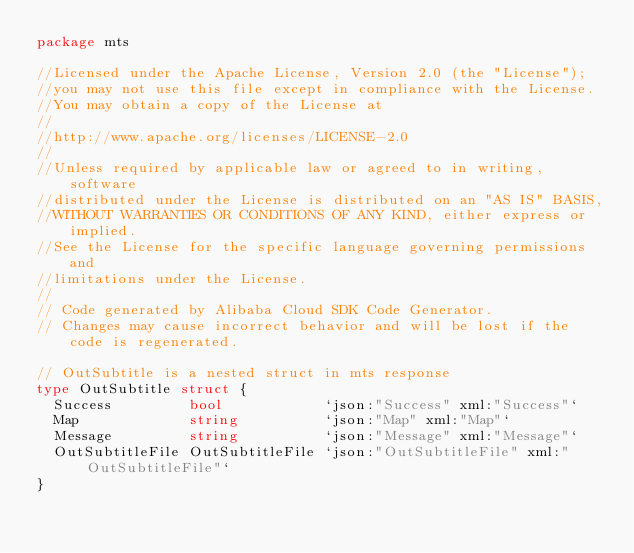<code> <loc_0><loc_0><loc_500><loc_500><_Go_>package mts

//Licensed under the Apache License, Version 2.0 (the "License");
//you may not use this file except in compliance with the License.
//You may obtain a copy of the License at
//
//http://www.apache.org/licenses/LICENSE-2.0
//
//Unless required by applicable law or agreed to in writing, software
//distributed under the License is distributed on an "AS IS" BASIS,
//WITHOUT WARRANTIES OR CONDITIONS OF ANY KIND, either express or implied.
//See the License for the specific language governing permissions and
//limitations under the License.
//
// Code generated by Alibaba Cloud SDK Code Generator.
// Changes may cause incorrect behavior and will be lost if the code is regenerated.

// OutSubtitle is a nested struct in mts response
type OutSubtitle struct {
	Success         bool            `json:"Success" xml:"Success"`
	Map             string          `json:"Map" xml:"Map"`
	Message         string          `json:"Message" xml:"Message"`
	OutSubtitleFile OutSubtitleFile `json:"OutSubtitleFile" xml:"OutSubtitleFile"`
}
</code> 